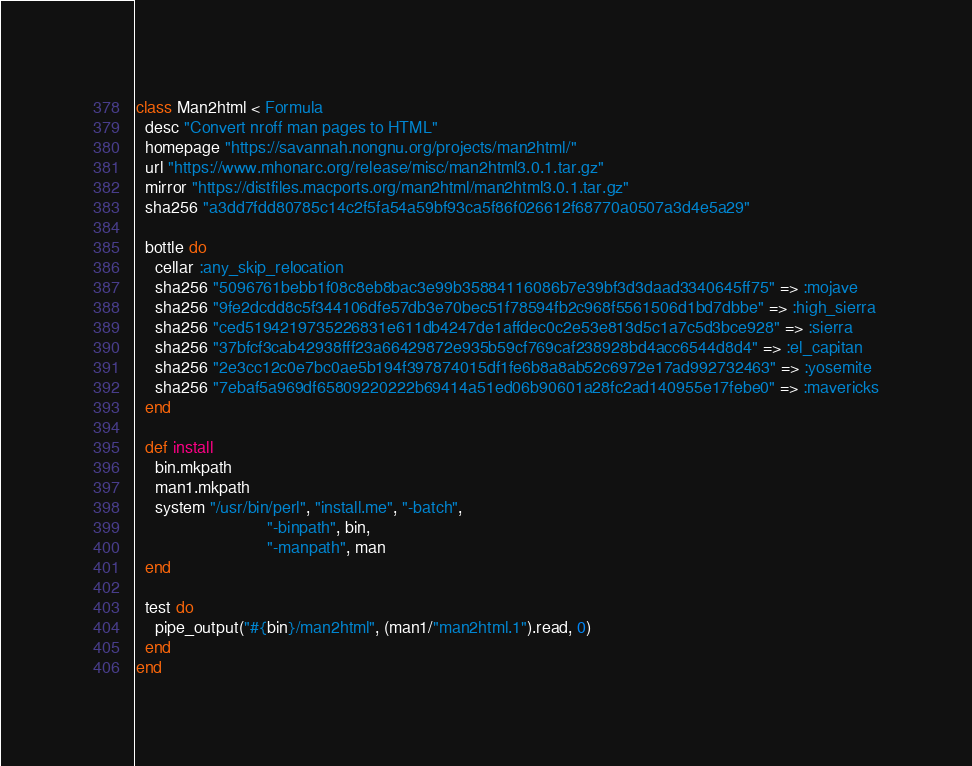<code> <loc_0><loc_0><loc_500><loc_500><_Ruby_>class Man2html < Formula
  desc "Convert nroff man pages to HTML"
  homepage "https://savannah.nongnu.org/projects/man2html/"
  url "https://www.mhonarc.org/release/misc/man2html3.0.1.tar.gz"
  mirror "https://distfiles.macports.org/man2html/man2html3.0.1.tar.gz"
  sha256 "a3dd7fdd80785c14c2f5fa54a59bf93ca5f86f026612f68770a0507a3d4e5a29"

  bottle do
    cellar :any_skip_relocation
    sha256 "5096761bebb1f08c8eb8bac3e99b35884116086b7e39bf3d3daad3340645ff75" => :mojave
    sha256 "9fe2dcdd8c5f344106dfe57db3e70bec51f78594fb2c968f5561506d1bd7dbbe" => :high_sierra
    sha256 "ced5194219735226831e611db4247de1affdec0c2e53e813d5c1a7c5d3bce928" => :sierra
    sha256 "37bfcf3cab42938fff23a66429872e935b59cf769caf238928bd4acc6544d8d4" => :el_capitan
    sha256 "2e3cc12c0e7bc0ae5b194f397874015df1fe6b8a8ab52c6972e17ad992732463" => :yosemite
    sha256 "7ebaf5a969df65809220222b69414a51ed06b90601a28fc2ad140955e17febe0" => :mavericks
  end

  def install
    bin.mkpath
    man1.mkpath
    system "/usr/bin/perl", "install.me", "-batch",
                            "-binpath", bin,
                            "-manpath", man
  end

  test do
    pipe_output("#{bin}/man2html", (man1/"man2html.1").read, 0)
  end
end
</code> 